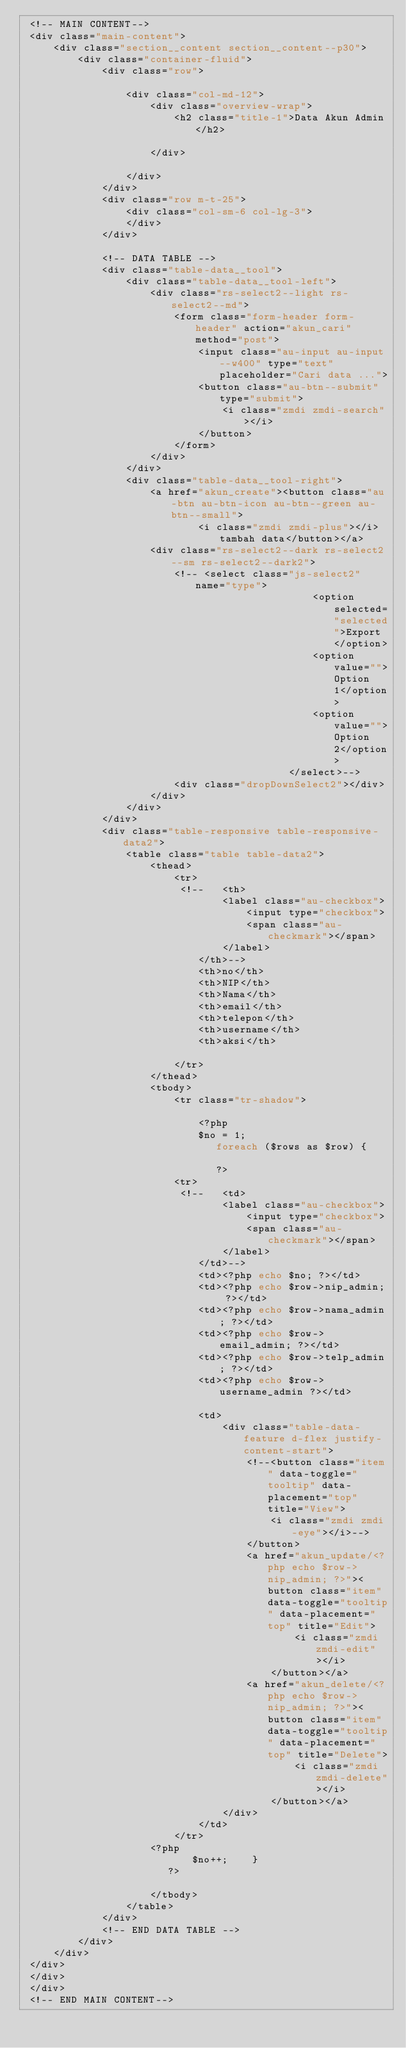<code> <loc_0><loc_0><loc_500><loc_500><_PHP_> <!-- MAIN CONTENT-->
 <div class="main-content">
     <div class="section__content section__content--p30">
         <div class="container-fluid">
             <div class="row">

                 <div class="col-md-12">
                     <div class="overview-wrap">
                         <h2 class="title-1">Data Akun Admin</h2>

                     </div>

                 </div>
             </div>
             <div class="row m-t-25">
                 <div class="col-sm-6 col-lg-3">
                 </div>
             </div>

             <!-- DATA TABLE -->
             <div class="table-data__tool">
                 <div class="table-data__tool-left">
                     <div class="rs-select2--light rs-select2--md">
                         <form class="form-header form-header" action="akun_cari" method="post">
                             <input class="au-input au-input--w400" type="text" placeholder="Cari data ...">
                             <button class="au-btn--submit" type="submit">
                                 <i class="zmdi zmdi-search"></i>
                             </button>
                         </form>
                     </div>
                 </div>
                 <div class="table-data__tool-right">
                     <a href="akun_create"><button class="au-btn au-btn-icon au-btn--green au-btn--small">
                             <i class="zmdi zmdi-plus"></i>tambah data</button></a>
                     <div class="rs-select2--dark rs-select2--sm rs-select2--dark2">
                         <!-- <select class="js-select2" name="type">
                                                <option selected="selected">Export</option>
                                                <option value="">Option 1</option>
                                                <option value="">Option 2</option>
                                            </select>-->
                         <div class="dropDownSelect2"></div>
                     </div>
                 </div>
             </div>
             <div class="table-responsive table-responsive-data2">
                 <table class="table table-data2">
                     <thead>
                         <tr>
                          <!--   <th>
                                 <label class="au-checkbox">
                                     <input type="checkbox">
                                     <span class="au-checkmark"></span>
                                 </label>
                             </th>-->
                             <th>no</th>
                             <th>NIP</th>
                             <th>Nama</th>
                             <th>email</th>
                             <th>telepon</th>
                             <th>username</th>
                             <th>aksi</th>

                         </tr>
                     </thead>
                     <tbody>
                         <tr class="tr-shadow">

                             <?php
                             $no = 1;
                                foreach ($rows as $row) {
                                    
                                ?>
                         <tr>
                          <!--   <td>
                                 <label class="au-checkbox">
                                     <input type="checkbox">
                                     <span class="au-checkmark"></span>
                                 </label>
                             </td>-->
                             <td><?php echo $no; ?></td>
                             <td><?php echo $row->nip_admin; ?></td>
                             <td><?php echo $row->nama_admin; ?></td>
                             <td><?php echo $row->email_admin; ?></td>
                             <td><?php echo $row->telp_admin; ?></td>
                             <td><?php echo $row->username_admin ?></td>

                             <td>
                                 <div class="table-data-feature d-flex justify-content-start">
                                     <!--<button class="item" data-toggle="tooltip" data-placement="top" title="View">
                                         <i class="zmdi zmdi-eye"></i>-->
                                     </button>
                                     <a href="akun_update/<?php echo $row->nip_admin; ?>"><button class="item" data-toggle="tooltip" data-placement="top" title="Edit">
                                             <i class="zmdi zmdi-edit"></i>
                                         </button></a>
                                     <a href="akun_delete/<?php echo $row->nip_admin; ?>"><button class="item" data-toggle="tooltip" data-placement="top" title="Delete">
                                             <i class="zmdi zmdi-delete"></i>
                                         </button></a>
                                 </div>
                             </td>
                         </tr>
                     <?php
                            $no++;    }
                        ?>

                     </tbody>
                 </table>
             </div>
             <!-- END DATA TABLE -->
         </div>
     </div>
 </div>
 </div>
 </div>
 <!-- END MAIN CONTENT--></code> 